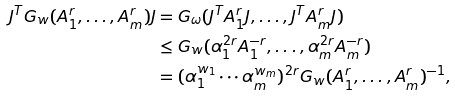Convert formula to latex. <formula><loc_0><loc_0><loc_500><loc_500>J ^ { T } G _ { w } ( A _ { 1 } ^ { r } , \dots , A _ { m } ^ { r } ) J & = G _ { \omega } ( J ^ { T } A _ { 1 } ^ { r } J , \dots , J ^ { T } A _ { m } ^ { r } J ) \\ & \leq G _ { w } ( \alpha _ { 1 } ^ { 2 r } A _ { 1 } ^ { - r } , \dots , \alpha _ { m } ^ { 2 r } A _ { m } ^ { - r } ) \\ & = ( \alpha _ { 1 } ^ { w _ { 1 } } \cdots \alpha _ { m } ^ { w _ { m } } ) ^ { 2 r } G _ { w } ( A _ { 1 } ^ { r } , \dots , A _ { m } ^ { r } ) ^ { - 1 } ,</formula> 